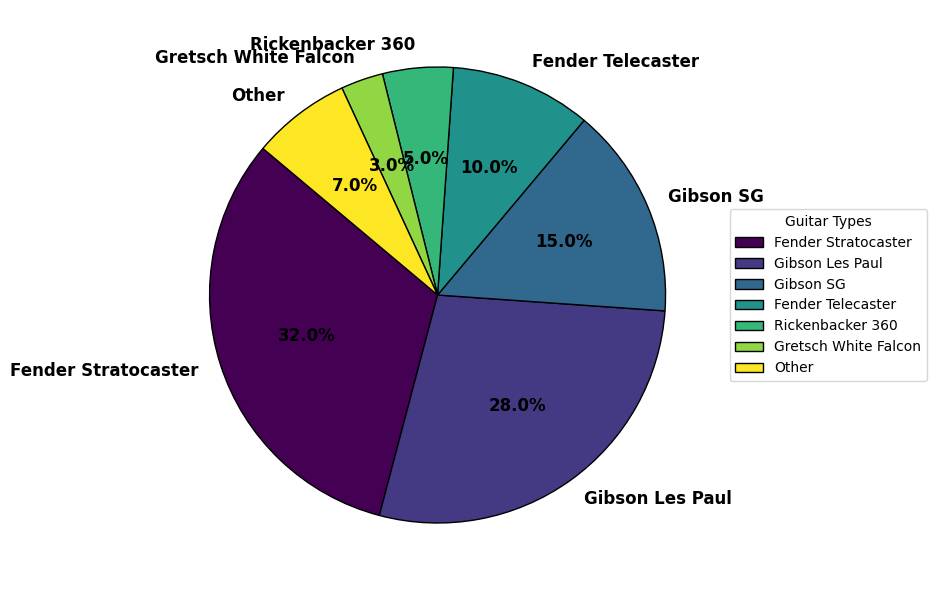What's the most commonly used guitar type in classic rock recordings? To determine the most commonly used guitar type, look at the guitar type with the largest percentage in the pie chart. The Fender Stratocaster segment is the largest at 32%.
Answer: Fender Stratocaster Which guitar type has the smallest representation in classic rock recordings? Identify the segment with the smallest percentage in the chart. The Gretsch White Falcon has the smallest segment at 3%.
Answer: Gretsch White Falcon Which has a higher percentage: Gibson SG or Fender Telecaster? Compare the percentages of Gibson SG and Fender Telecaster. Gibson SG has 15% while Fender Telecaster has 10%. Therefore, Gibson SG has a higher percentage.
Answer: Gibson SG What is the combined percentage of Gibson Les Paul and Rickenbacker 360? Add the percentages of Gibson Les Paul and Rickenbacker 360. Gibson Les Paul is 28% and Rickenbacker 360 is 5%. Therefore, the combined percentage is 28% + 5% = 33%.
Answer: 33% How does the representation of Fender guitars (Stratocaster and Telecaster) compare to that of Gibson guitars (Les Paul and SG)? Sum the percentages of Fender guitars (Stratocaster: 32% and Telecaster: 10%) and Gibson guitars (Les Paul: 28% and SG: 15%). Fender guitars total 32% + 10% = 42%, and Gibson guitars total 28% + 15% = 43%. Therefore, Gibson guitars have a slightly higher combined representation by 1%.
Answer: Gibson guitars have a slightly higher representation by 1% What is the difference in the combined percentage of Fender guitars (Stratocaster and Telecaster) and the "Other" category? Calculate the combined percentage of Fender guitars as 32 + 10 = 42%. The "Other" category is 7%. The difference is 42% - 7% = 35%.
Answer: 35% If you were to sum up the percentages represented by the Fender Telecaster, Rickenbacker 360, and Gretsch White Falcon, what would be the total? Add the percentages of these three guitar types. Fender Telecaster is 10%, Rickenbacker 360 is 5%, and Gretsch White Falcon is 3%. Thus, the total is 10% + 5% + 3% = 18%.
Answer: 18% How many more percentage points does Gibson Les Paul have compared to Gibson SG? Subtract the percentage of Gibson SG from Gibson Les Paul. Gibson Les Paul is 28% and Gibson SG is 15%, so the difference is 28% - 15% = 13%.
Answer: 13% Which guitar type represents more than one-quarter but less than one-third of the total? Identify the guitar type with a percentage greater than 25% (one-quarter) but less than 33.3% (one-third). The Fender Stratocaster is at 32%, which falls within this range.
Answer: Fender Stratocaster 